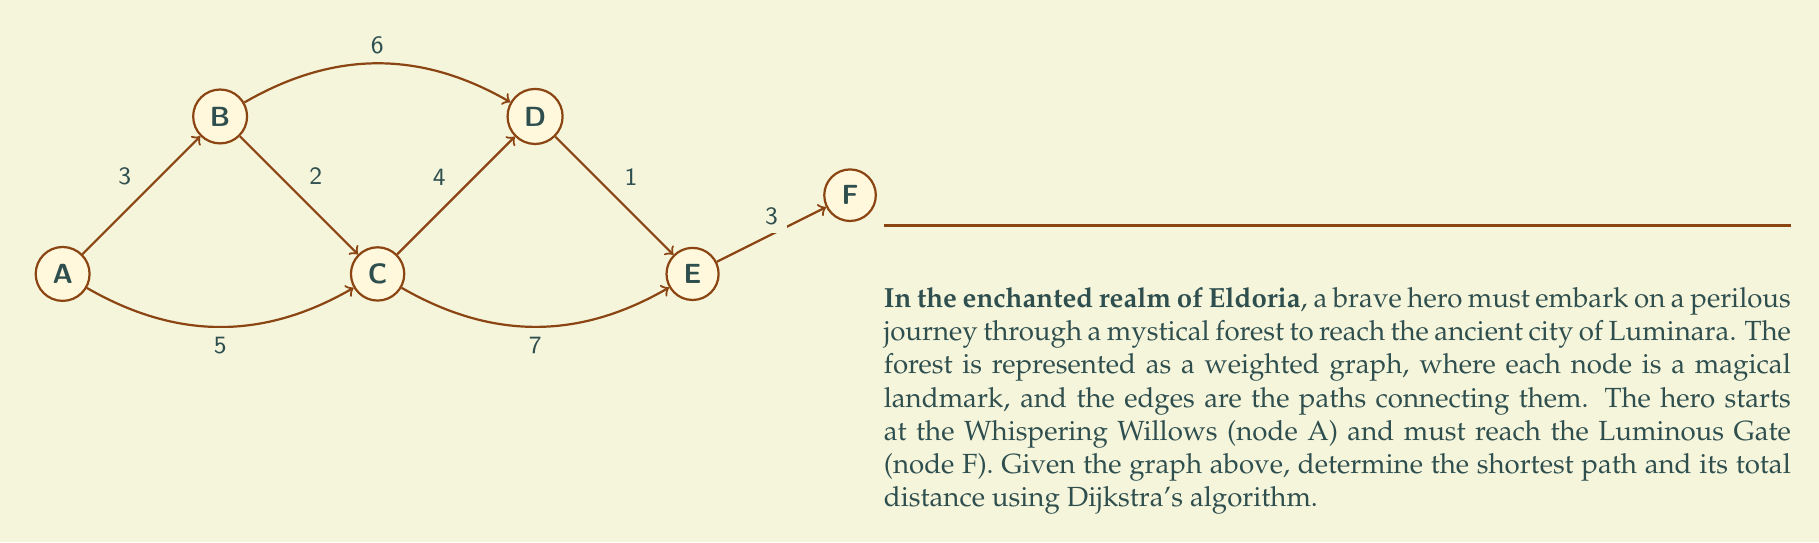Could you help me with this problem? To solve this problem, we'll use Dijkstra's algorithm to find the shortest path from node A to node F. Let's follow the steps:

1. Initialize:
   - Set distance to A as 0, and all other nodes as infinity.
   - Set all nodes as unvisited.
   - Set A as the current node.

2. For the current node, consider all unvisited neighbors and calculate their tentative distances.
   - Update the neighbor's distance if the calculated distance is less than the previously recorded distance.

3. Mark the current node as visited and remove it from the unvisited set.

4. If the destination node (F) has been marked visited, we're done.
   Otherwise, select the unvisited node with the smallest tentative distance and set it as the new current node. Go back to step 2.

Let's apply the algorithm:

Starting at A:
- Update B: min(∞, 0 + 3) = 3
- Update C: min(∞, 0 + 5) = 5

Mark A as visited. Current shortest paths:
A → B (3)
A → C (5)

Select B as the current node:
- Update D: min(∞, 3 + 6) = 9
- Update C: min(5, 3 + 2) = 5 (no change)

Mark B as visited. Current shortest paths:
A → B (3)
A → C (5)
A → B → D (9)

Select C as the current node:
- Update D: min(9, 5 + 4) = 9 (no change)
- Update E: min(∞, 5 + 7) = 12

Mark C as visited. Current shortest paths:
A → B (3)
A → C (5)
A → B → D (9)
A → C → E (12)

Select D as the current node:
- Update E: min(12, 9 + 1) = 10

Mark D as visited. Current shortest paths:
A → B (3)
A → C (5)
A → B → D (9)
A → B → D → E (10)

Select E as the current node:
- Update F: min(∞, 10 + 3) = 13

Mark E as visited. Current shortest path to F:
A → B → D → E → F (13)

As F is now visited, we have found the shortest path.
Answer: The shortest path is A → B → D → E → F, with a total distance of 13 units. 